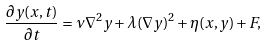Convert formula to latex. <formula><loc_0><loc_0><loc_500><loc_500>\frac { \partial y ( x , t ) } { \partial t } = \nu \nabla ^ { 2 } y + \lambda ( \nabla y ) ^ { 2 } + \eta ( x , y ) + F ,</formula> 